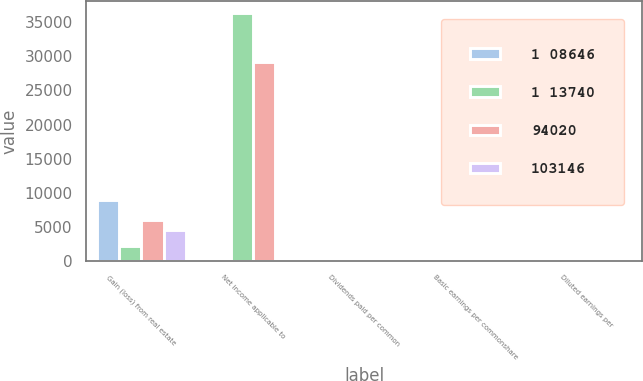Convert chart. <chart><loc_0><loc_0><loc_500><loc_500><stacked_bar_chart><ecel><fcel>Gain (loss) from real estate<fcel>Net income applicable to<fcel>Dividends paid per common<fcel>Basic earnings per commonshare<fcel>Diluted earnings per<nl><fcel>1 08646<fcel>9008<fcel>0.42<fcel>0.42<fcel>0.32<fcel>0.31<nl><fcel>1 13740<fcel>2176<fcel>36302<fcel>0.42<fcel>0.28<fcel>0.27<nl><fcel>94020<fcel>6036<fcel>29208<fcel>0.42<fcel>0.22<fcel>0.22<nl><fcel>103146<fcel>4527<fcel>0.42<fcel>0.42<fcel>0.31<fcel>0.3<nl></chart> 